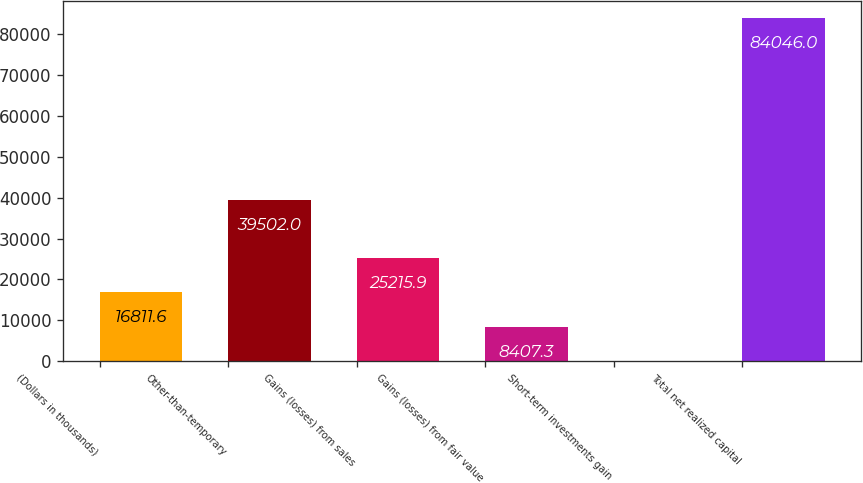Convert chart to OTSL. <chart><loc_0><loc_0><loc_500><loc_500><bar_chart><fcel>(Dollars in thousands)<fcel>Other-than-temporary<fcel>Gains (losses) from sales<fcel>Gains (losses) from fair value<fcel>Short-term investments gain<fcel>Total net realized capital<nl><fcel>16811.6<fcel>39502<fcel>25215.9<fcel>8407.3<fcel>3<fcel>84046<nl></chart> 